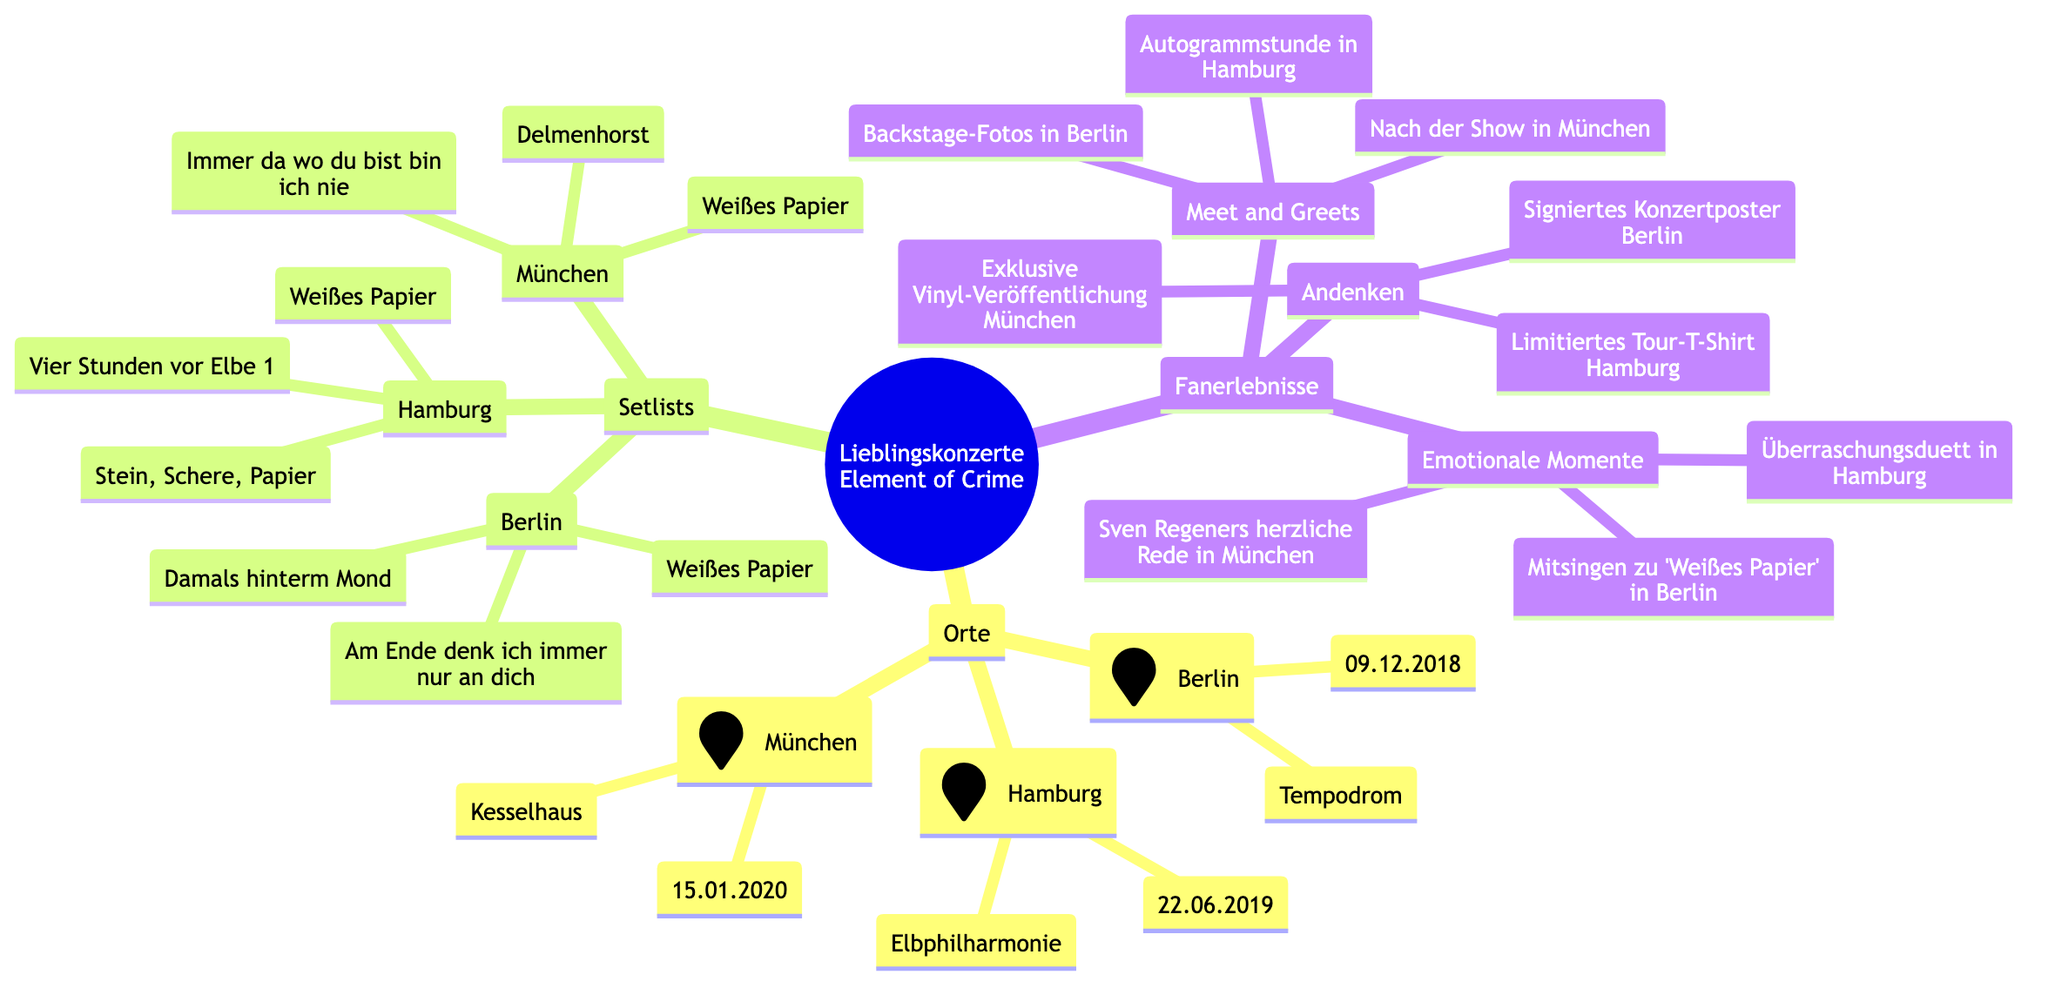What is the venue in Berlin? The diagram shows that the venue for the Berlin concert is "Tempodrom" under the "Locations" section.
Answer: Tempodrom What was the date of the concert in Hamburg? According to the diagram, the Hamburg concert took place on "22.06.2019" listed next to the venue "Elbphilharmonie."
Answer: 22.06.2019 Which song was performed in all three concerts? By looking at the "Setlists" section, "Weißes Papier" is the only song that appears under the setlists for Berlin, Hamburg, and Munich.
Answer: Weißes Papier Name one emotional moment from the Munich concert. The diagram lists "Sven Regeners herzliche Rede in München" under the "Emotionale Momente" section, indicating a special moment experienced there.
Answer: Sven Regeners herzliche Rede in München How many meet and greet events are mentioned? In the "Meet and Greets" section, there are three events listed (Berlin, Hamburg, and Munich), so counting these gives a total of three meet and greet opportunities.
Answer: 3 What type of memorabilia was offered at the Hamburg concert? Under "Andenken", the diagram specifies "Limitiertes Tour-T-Shirt Hamburg" as the type of memorabilia available during the Hamburg concert.
Answer: Limitiertes Tour-T-Shirt Hamburg Which location features a duet in the fan experiences? The "Überraschungsduett in Hamburg" is mentioned in the "Emotionale Momente" section, indicating that the duet experience occurred in Hamburg.
Answer: Hamburg What setlist item directly follows "Immer da wo du bist bin ich nie"? The setlist for Munich includes "Weißes Papier" as the item that follows "Immer da wo du bist bin ich nie". It is listed in order under the "Setlists" section for Munich.
Answer: Weißes Papier How many locations are highlighted in the concert memories? The "Locations" section lists three distinct locations: Berlin, Hamburg, and Munich, so the count of these listed locations is three.
Answer: 3 